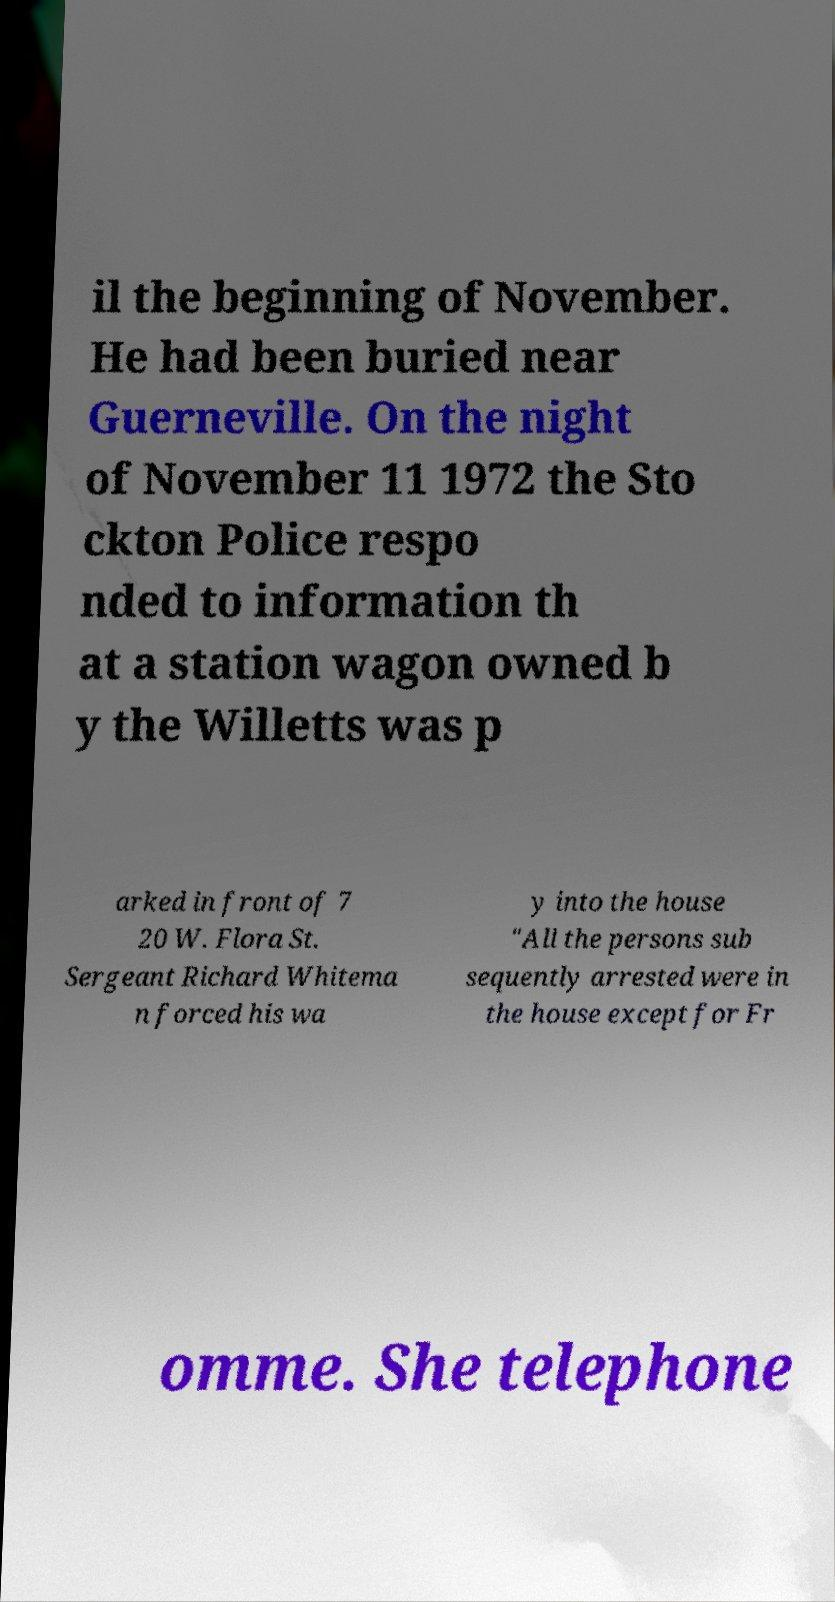Could you assist in decoding the text presented in this image and type it out clearly? il the beginning of November. He had been buried near Guerneville. On the night of November 11 1972 the Sto ckton Police respo nded to information th at a station wagon owned b y the Willetts was p arked in front of 7 20 W. Flora St. Sergeant Richard Whitema n forced his wa y into the house "All the persons sub sequently arrested were in the house except for Fr omme. She telephone 